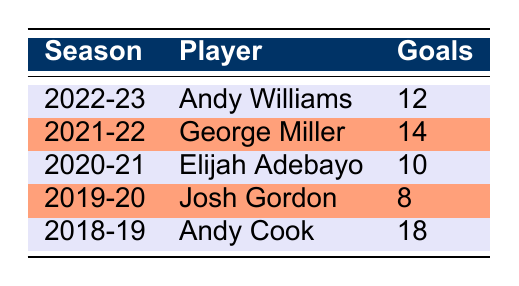What was the highest number of goals scored by a player in a single season? Looking at the table, the highest number of goals is 18, scored by Andy Cook in the 2018-19 season.
Answer: 18 Who was Walsall FC's top goalscorer in the 2021-22 season? Referring to the table, George Miller scored the most goals that season, with a total of 14.
Answer: George Miller Did Elijah Adebayo score more goals than Josh Gordon? According to the table, Elijah Adebayo scored 10 goals and Josh Gordon scored 8 goals, so yes, Adebayo scored more.
Answer: Yes How many total goals were scored by the top goalscorers from the last five seasons? Adding the goals: 12 (Williams) + 14 (Miller) + 10 (Adebayo) + 8 (Gordon) + 18 (Cook) = 62. Thus, the total is 62 goals.
Answer: 62 Was Andy Williams the only player to score in double digits in the 2022-23 season? The table indicates that Andy Williams scored 12 goals, and there are no other players listed from that season, making him the sole player in double digits.
Answer: Yes Which player had the lowest goal tally in a single season over the past five years? The table shows that Josh Gordon scored the fewest goals, with only 8 in the 2019-20 season.
Answer: Josh Gordon What is the average number of goals scored by the top goalscorers over the past five seasons? To find the average, sum the goals (62) and divide by the number of players (5): 62/5 = 12.4.
Answer: 12.4 Did Andy Cook score more goals than Andy Williams and George Miller combined? Andy Cook scored 18 goals, while Williams (12) and Miller (14) together scored 26 goals (12 + 14 = 26). So, Cook did not score more than their combined total.
Answer: No 